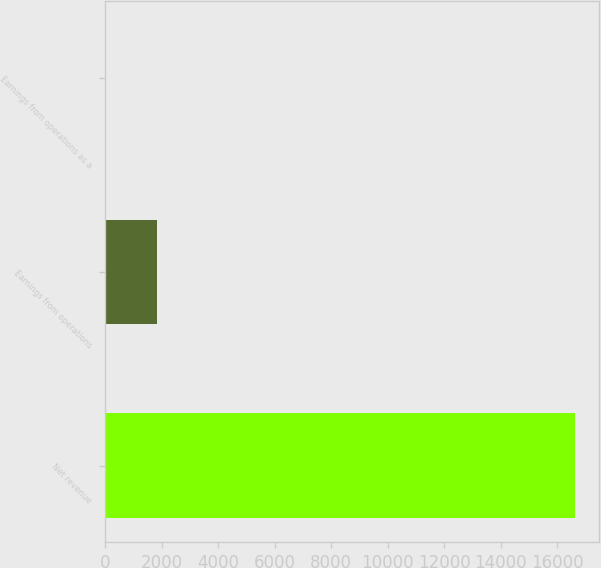Convert chart to OTSL. <chart><loc_0><loc_0><loc_500><loc_500><bar_chart><fcel>Net revenue<fcel>Earnings from operations<fcel>Earnings from operations as a<nl><fcel>16646<fcel>1829<fcel>11<nl></chart> 